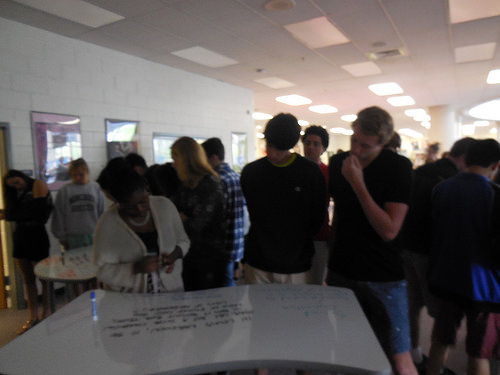<image>
Is the trouser under the boy? No. The trouser is not positioned under the boy. The vertical relationship between these objects is different. Where is the girl in relation to the table? Is it behind the table? Yes. From this viewpoint, the girl is positioned behind the table, with the table partially or fully occluding the girl. 